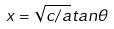Convert formula to latex. <formula><loc_0><loc_0><loc_500><loc_500>x = \sqrt { c / a } t a n \theta</formula> 